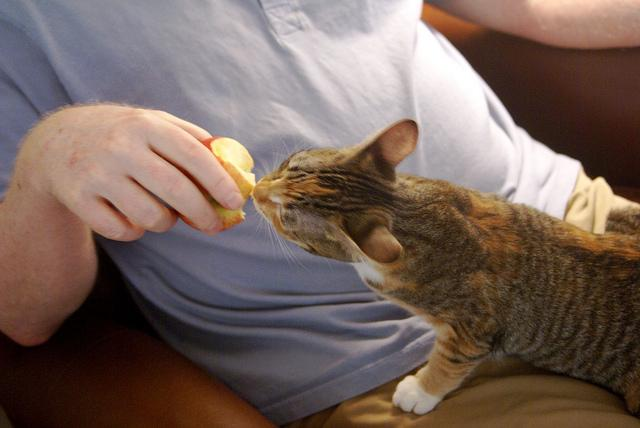Where do apples originate from?

Choices:
A) australia
B) europe
C) england
D) asia asia 